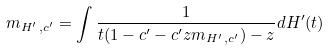Convert formula to latex. <formula><loc_0><loc_0><loc_500><loc_500>m _ { H ^ { \prime } \, , c ^ { \prime } } = \int \frac { 1 } { t ( 1 - c ^ { \prime } - c ^ { \prime } z m _ { H ^ { \prime } \, , c ^ { \prime } } ) - z } d H ^ { \prime } ( t )</formula> 